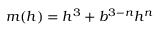Convert formula to latex. <formula><loc_0><loc_0><loc_500><loc_500>m ( h ) = h ^ { 3 } + b ^ { 3 - n } h ^ { n }</formula> 